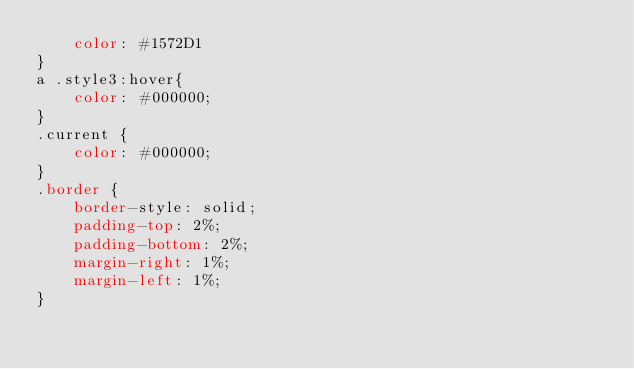Convert code to text. <code><loc_0><loc_0><loc_500><loc_500><_CSS_>    color: #1572D1
}
a .style3:hover{
    color: #000000;
}
.current {
    color: #000000;
}
.border {
    border-style: solid;
    padding-top: 2%;
    padding-bottom: 2%;
    margin-right: 1%;
    margin-left: 1%;
}
</code> 